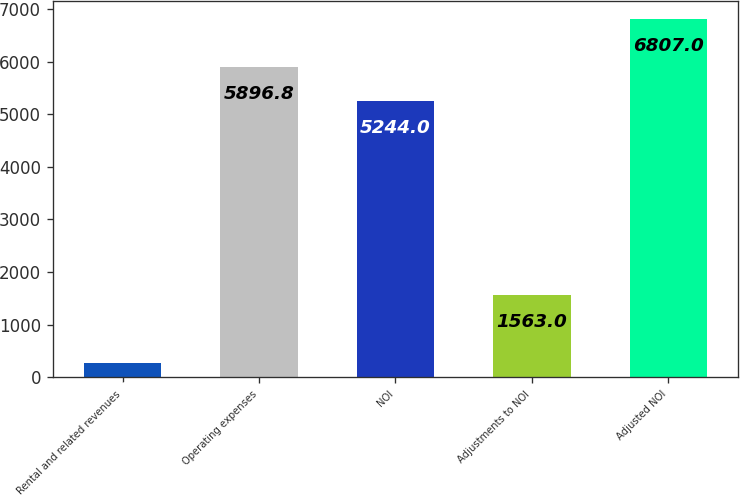<chart> <loc_0><loc_0><loc_500><loc_500><bar_chart><fcel>Rental and related revenues<fcel>Operating expenses<fcel>NOI<fcel>Adjustments to NOI<fcel>Adjusted NOI<nl><fcel>279<fcel>5896.8<fcel>5244<fcel>1563<fcel>6807<nl></chart> 